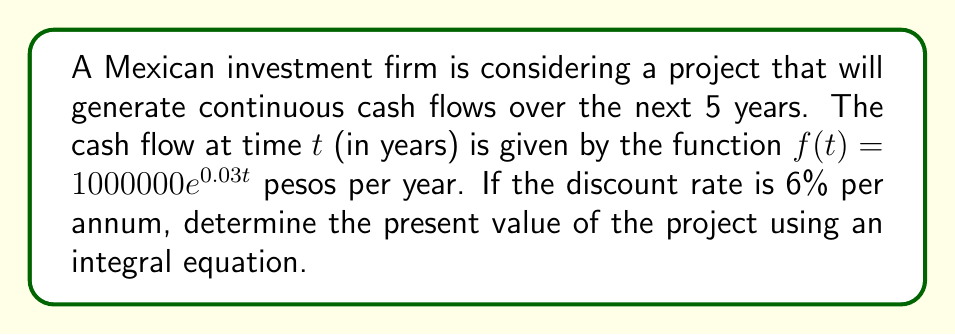What is the answer to this math problem? To solve this problem, we'll follow these steps:

1) The present value (PV) of a continuous cash flow stream is given by the integral:

   $$PV = \int_0^T f(t)e^{-rt} dt$$

   where $f(t)$ is the cash flow function, $r$ is the discount rate, and $T$ is the time horizon.

2) In this case, $f(t) = 1000000e^{0.03t}$, $r = 0.06$, and $T = 5$.

3) Substituting these into the integral:

   $$PV = \int_0^5 1000000e^{0.03t}e^{-0.06t} dt$$

4) Simplify the exponent:

   $$PV = \int_0^5 1000000e^{-0.03t} dt$$

5) Evaluate the integral:

   $$PV = 1000000 \left[-\frac{1}{0.03}e^{-0.03t}\right]_0^5$$

6) Solve:

   $$PV = 1000000 \left[-\frac{1}{0.03}e^{-0.03(5)} + \frac{1}{0.03}\right]$$
   
   $$PV = 1000000 \left[-33.33e^{-0.15} + 33.33\right]$$
   
   $$PV = 1000000 [28.61 + 33.33] = 4,614,000$$

Therefore, the present value of the project is approximately 4,614,000 pesos.
Answer: 4,614,000 pesos 